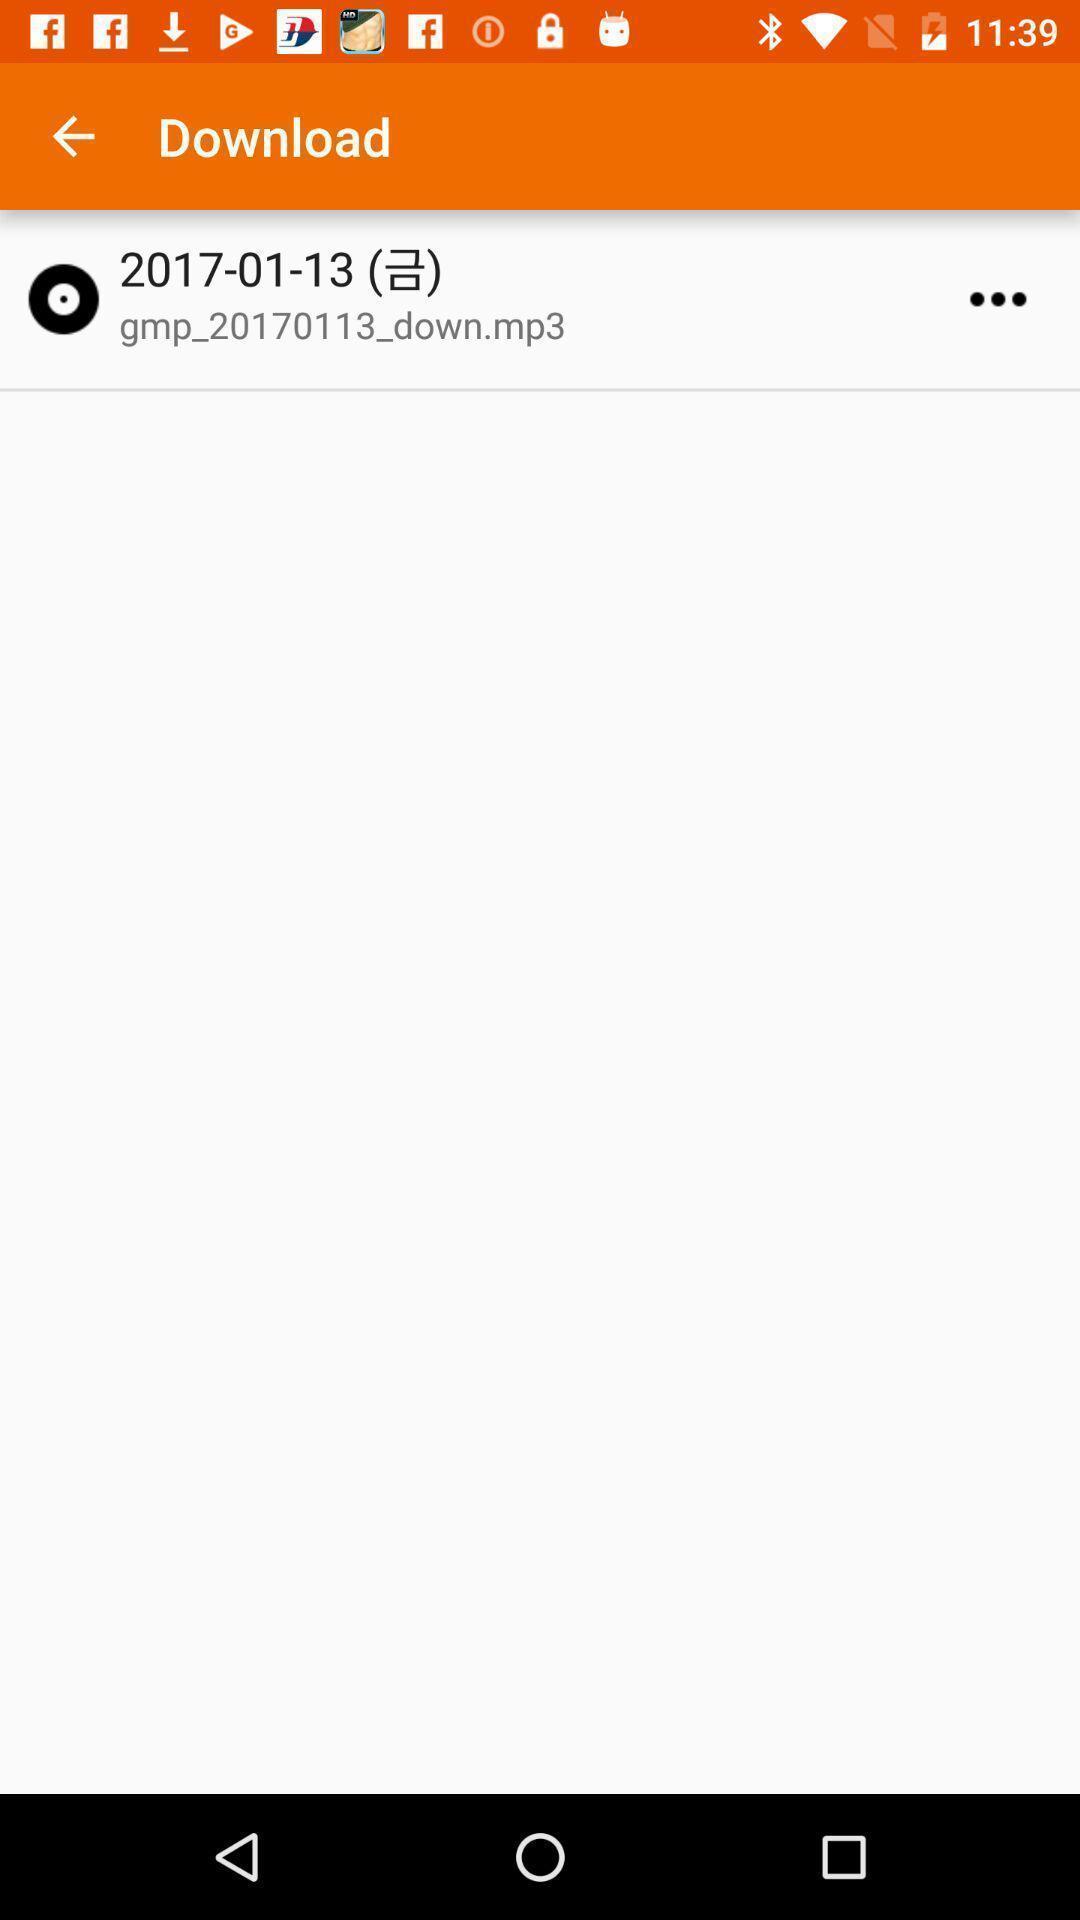Explain the elements present in this screenshot. Screen display download page. 